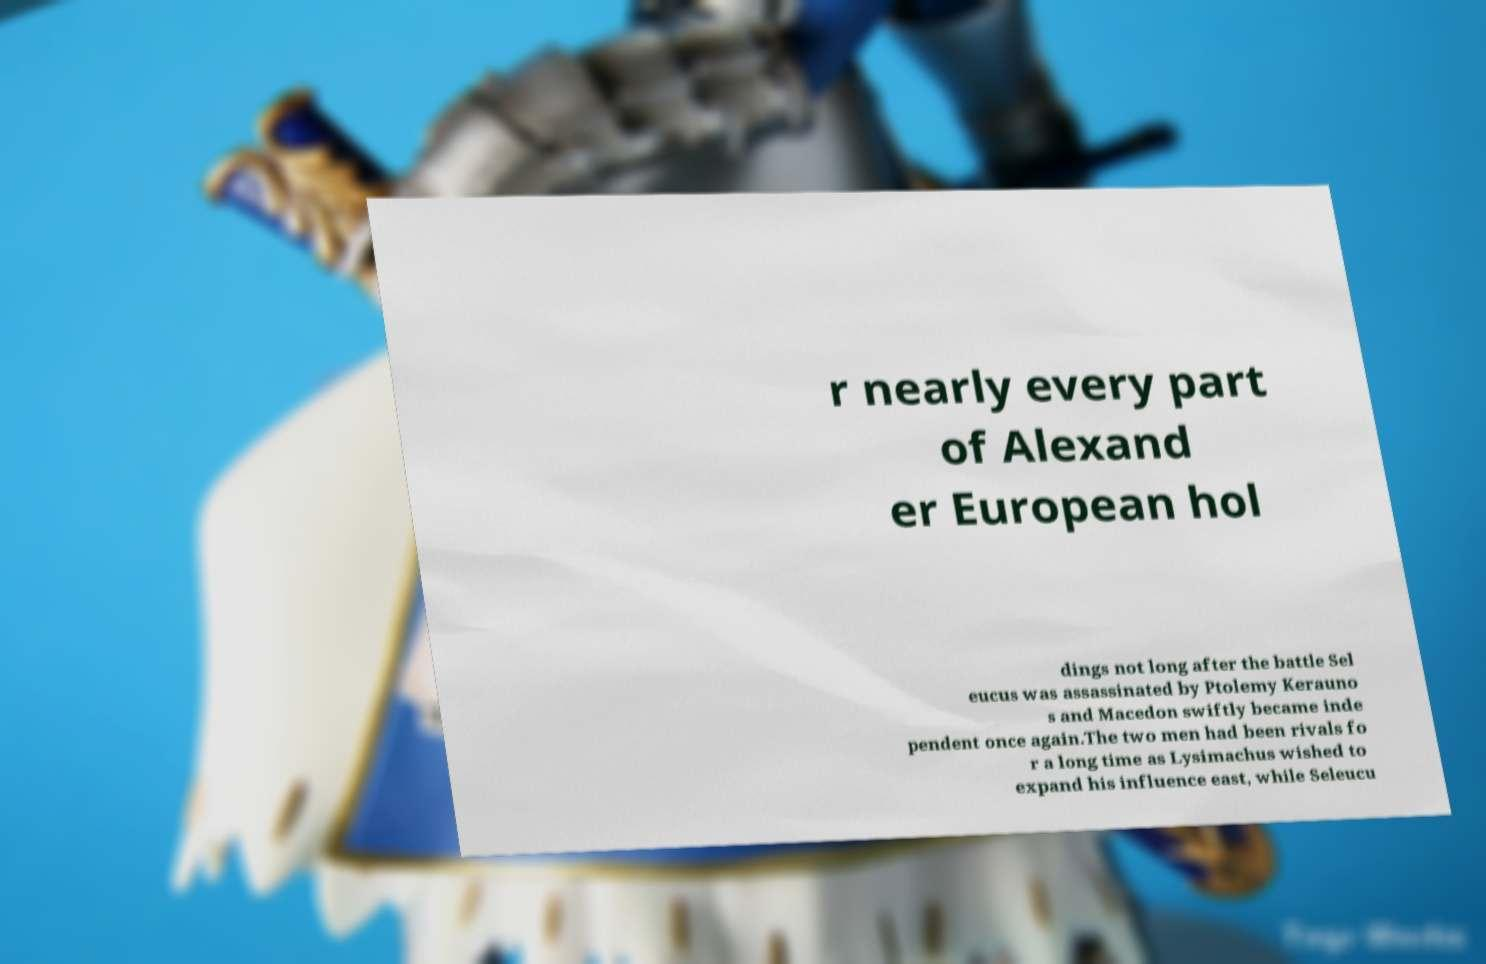Please identify and transcribe the text found in this image. r nearly every part of Alexand er European hol dings not long after the battle Sel eucus was assassinated by Ptolemy Kerauno s and Macedon swiftly became inde pendent once again.The two men had been rivals fo r a long time as Lysimachus wished to expand his influence east, while Seleucu 